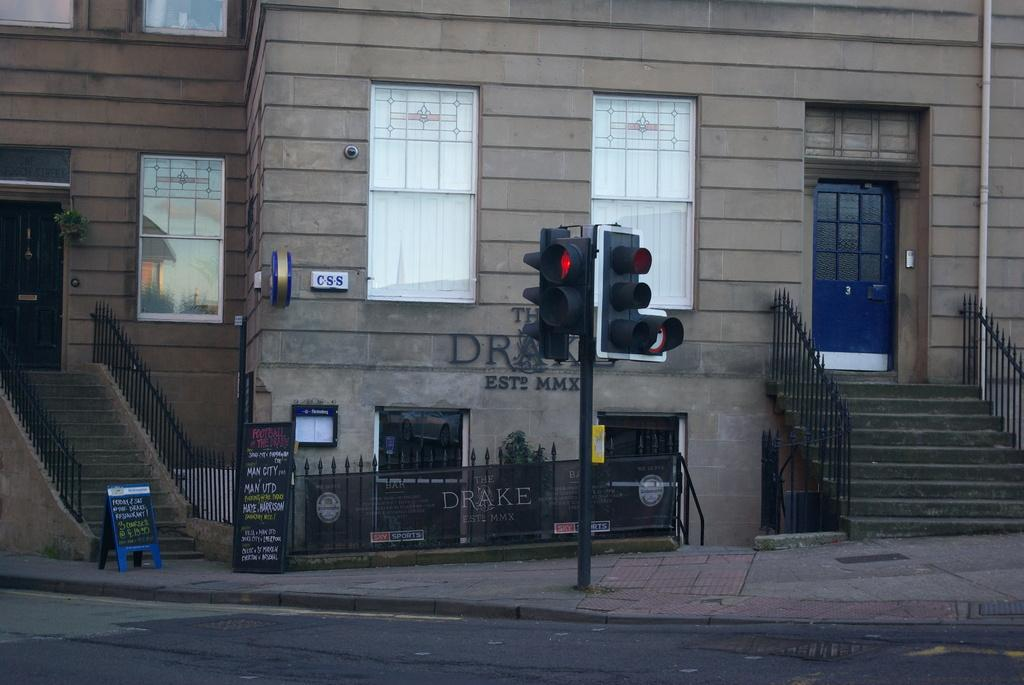What is the main subject of the image? The main subject of the image is a traffic light signal. How is the traffic light signal positioned in the image? The traffic light signal is attached to a pole. What can be seen in the background of the image? There is a building in the background of the image. Can you see a man kissing a wheel in the image? No, there is no man or wheel present in the image. 